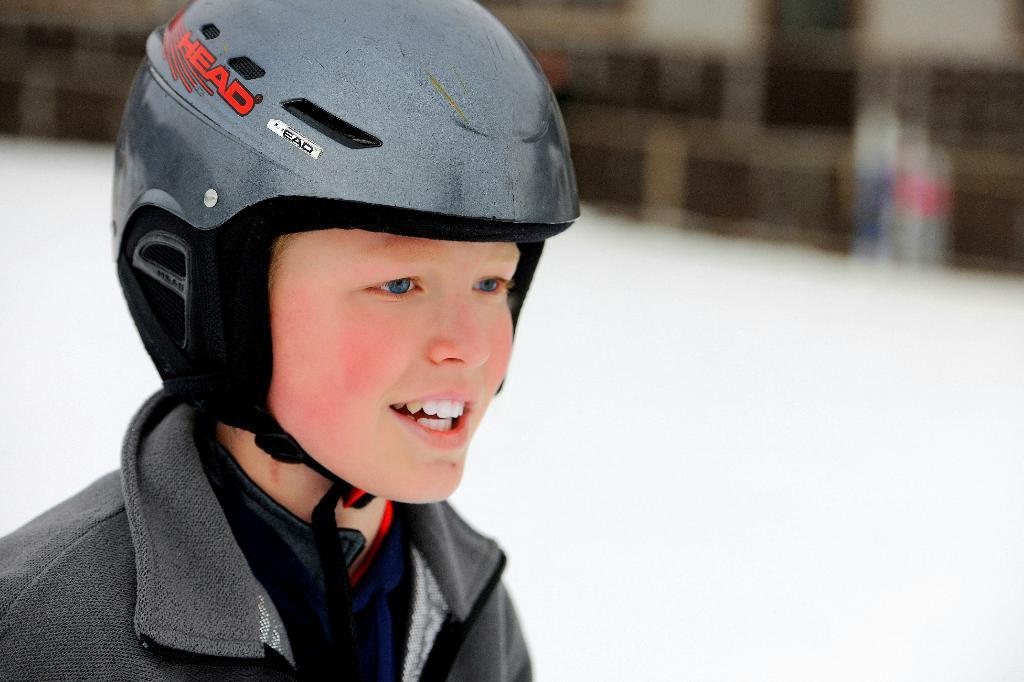Could you give a brief overview of what you see in this image? In this image, I can see a boy with a helmet. The background looks blurry. 